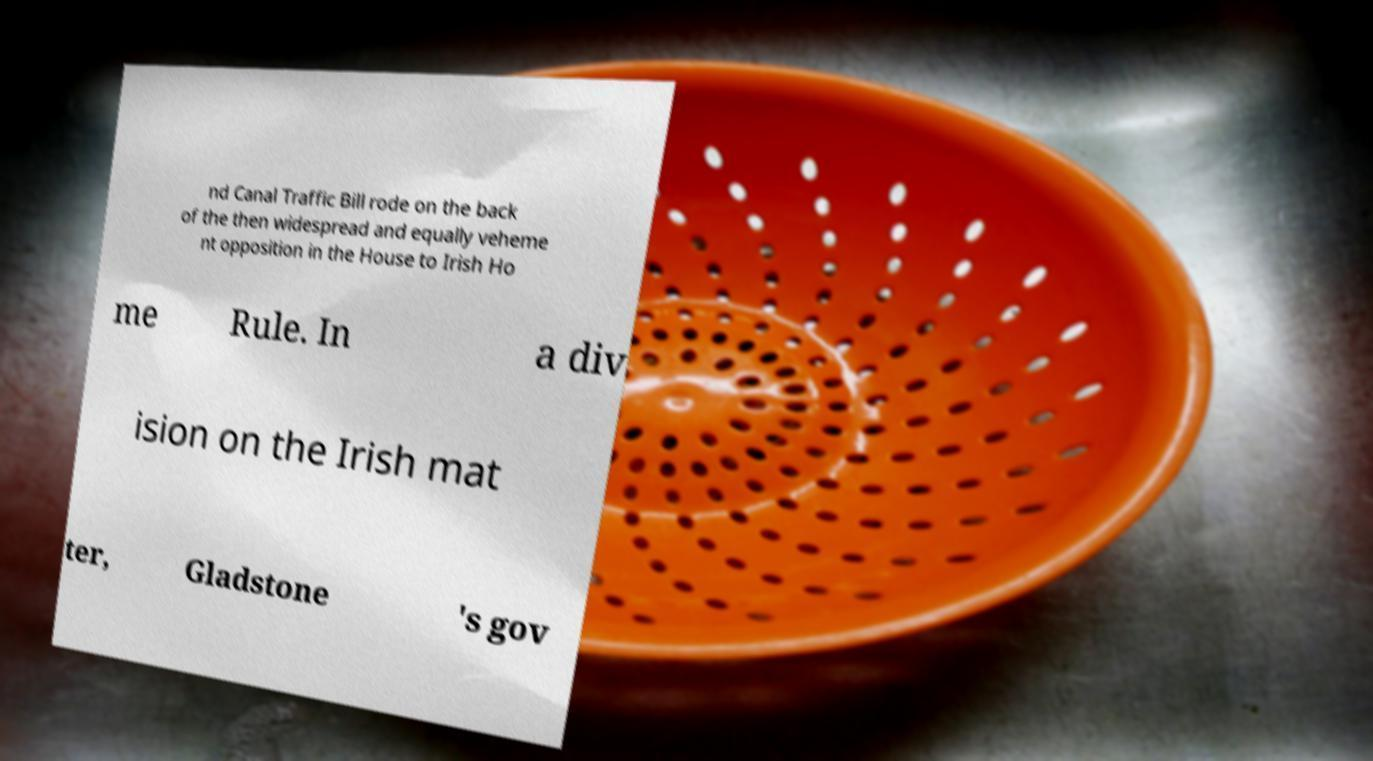What messages or text are displayed in this image? I need them in a readable, typed format. nd Canal Traffic Bill rode on the back of the then widespread and equally veheme nt opposition in the House to Irish Ho me Rule. In a div ision on the Irish mat ter, Gladstone 's gov 